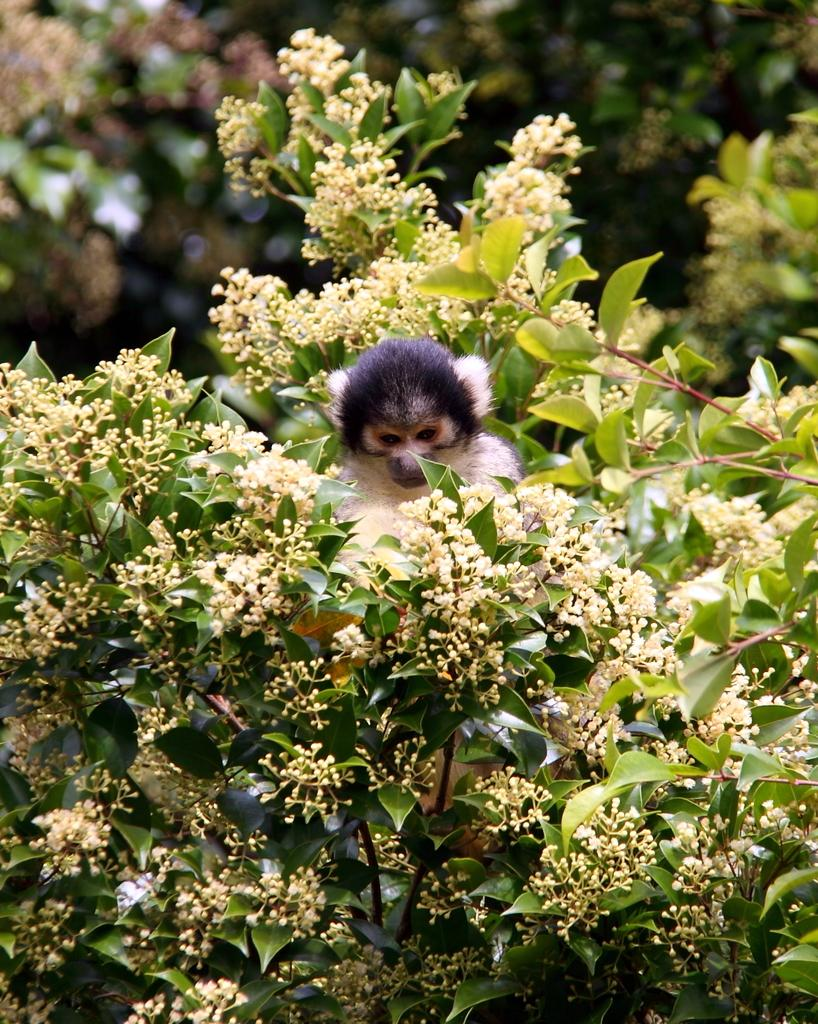What type of living organisms can be seen in the image? Plants are visible in the image. What other living organism can be seen in the image? There is an animal in the image. Can you describe the background of the image? The background of the image is blurry. What type of basket is the boy holding in the image? There is no boy or basket present in the image. 